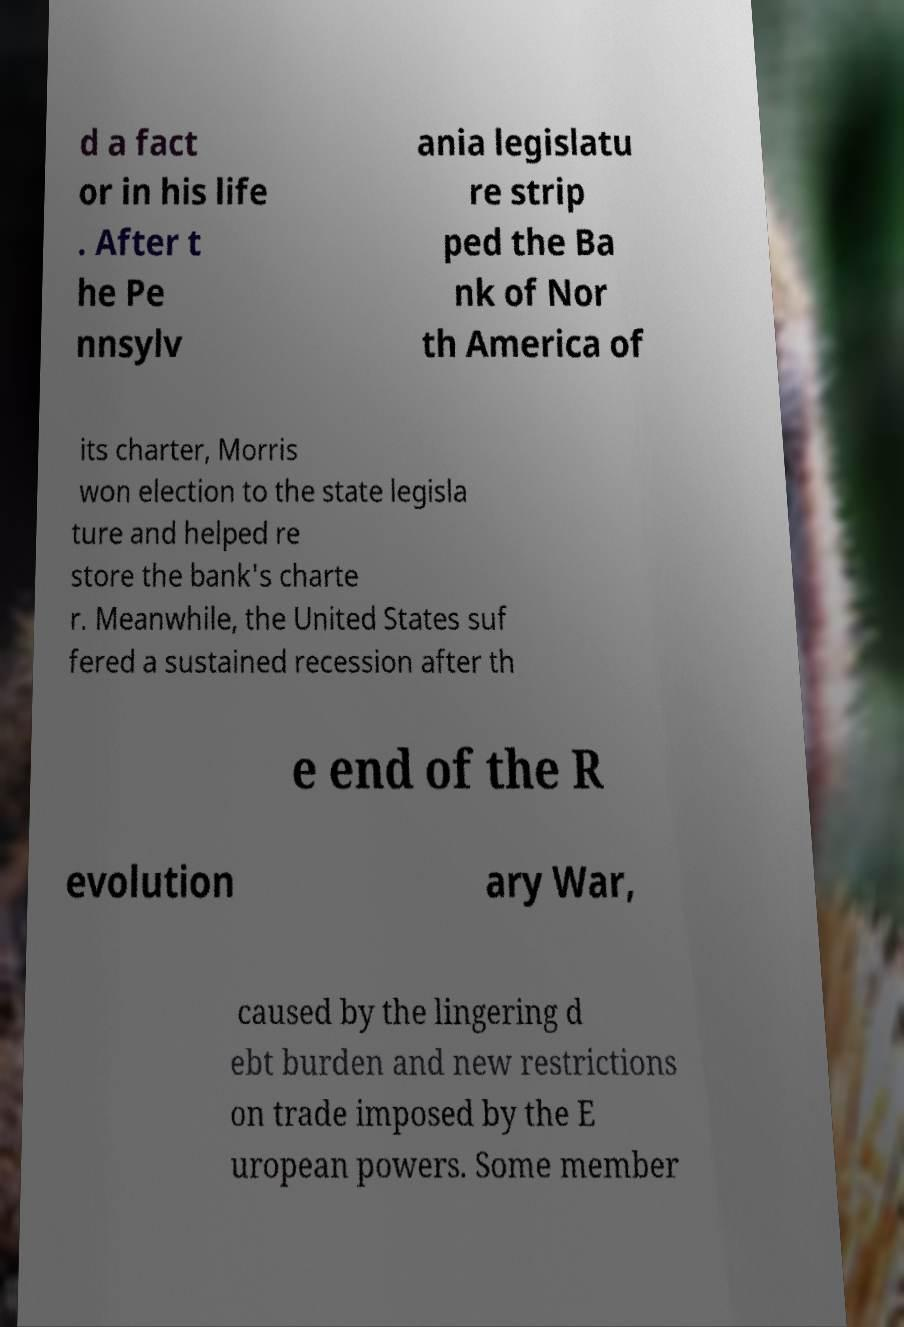Can you accurately transcribe the text from the provided image for me? d a fact or in his life . After t he Pe nnsylv ania legislatu re strip ped the Ba nk of Nor th America of its charter, Morris won election to the state legisla ture and helped re store the bank's charte r. Meanwhile, the United States suf fered a sustained recession after th e end of the R evolution ary War, caused by the lingering d ebt burden and new restrictions on trade imposed by the E uropean powers. Some member 